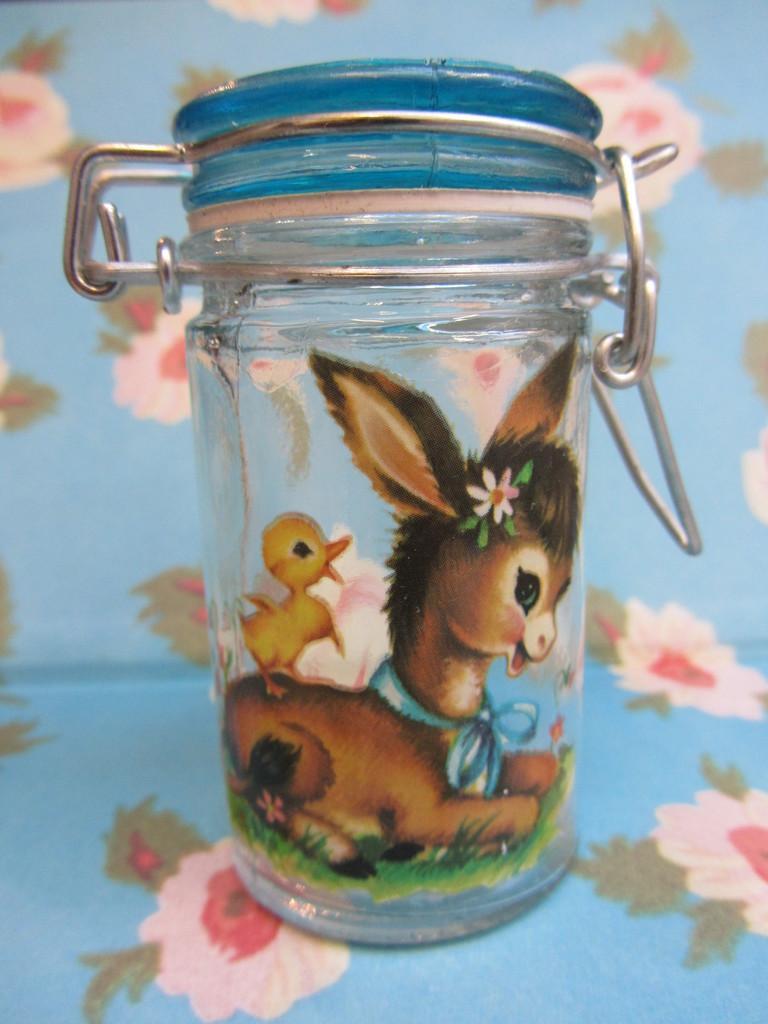Describe this image in one or two sentences. In this image we can see a glass container with some animal paintings on it. In the background, we can see flowers paintings on the blue color surface. 